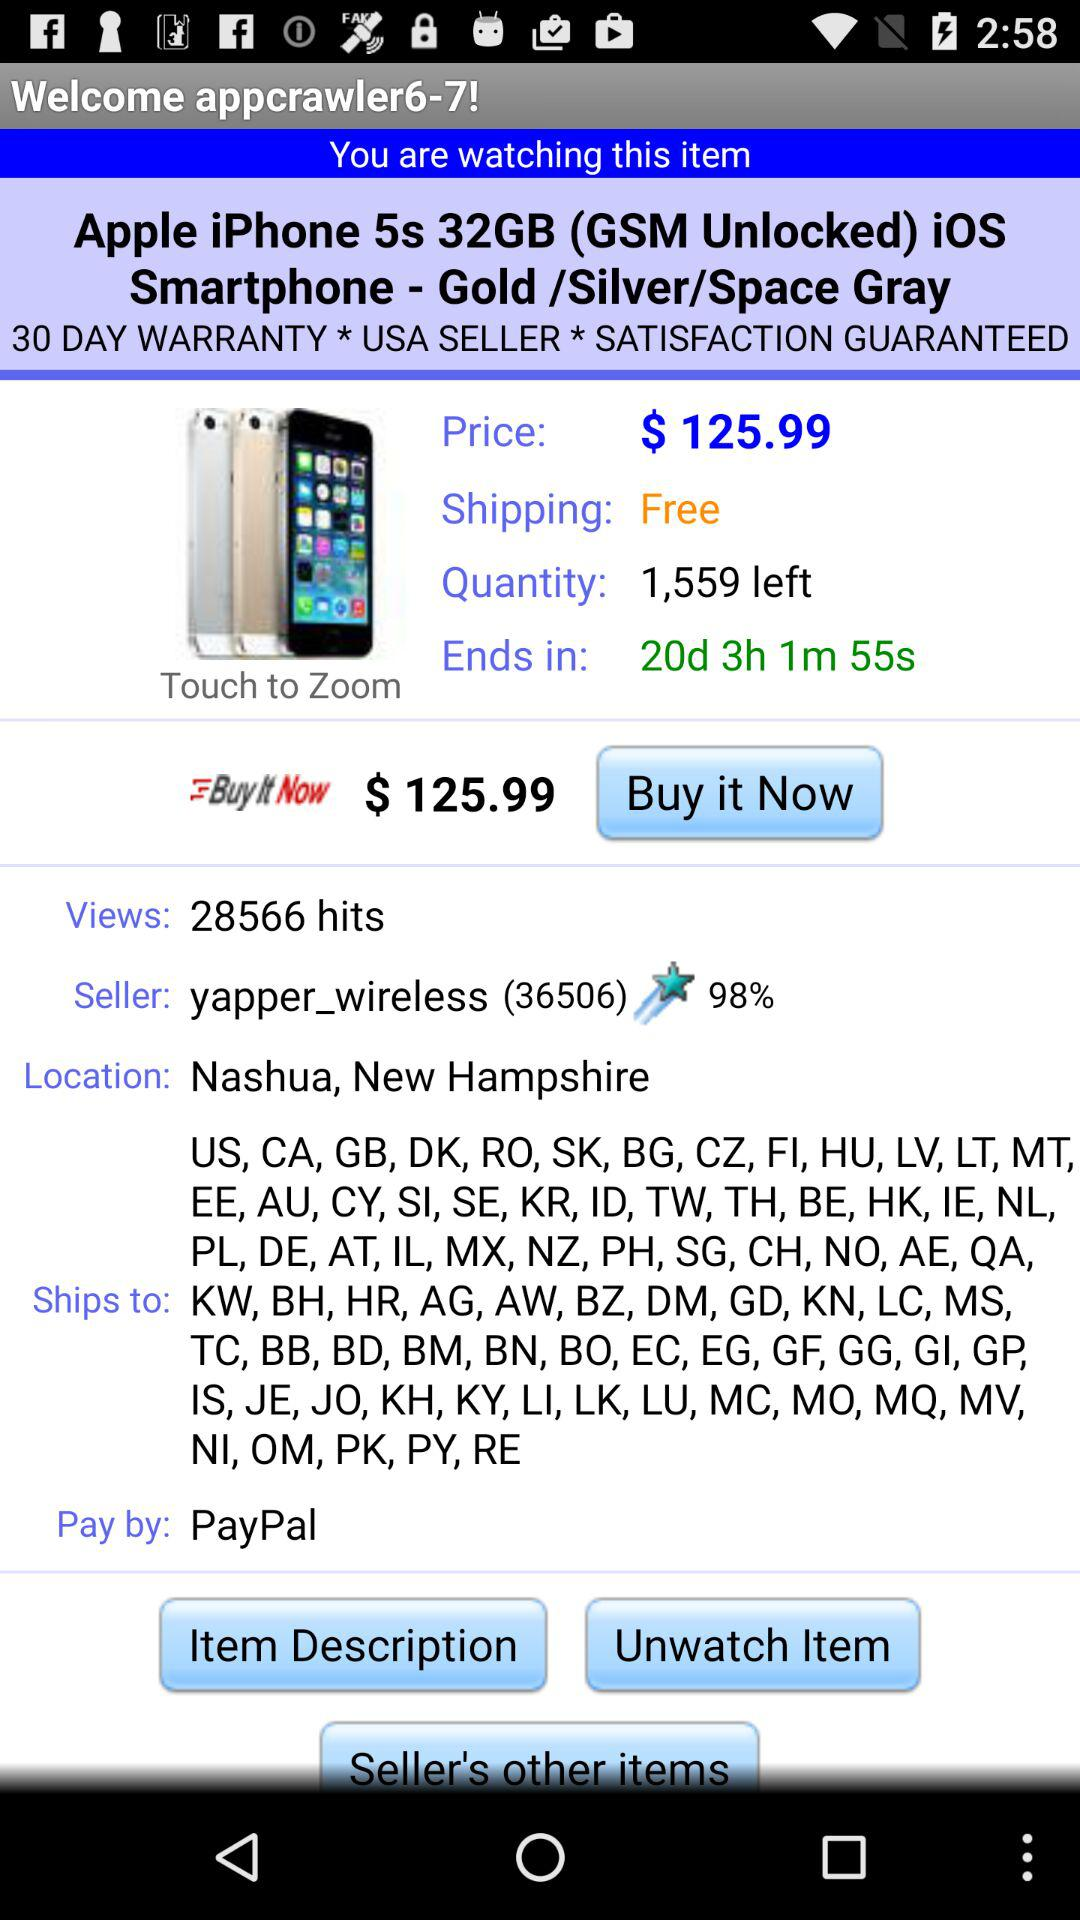How many days of warranty does the phone have? There is a 30-day warranty on the phone. 